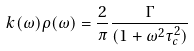Convert formula to latex. <formula><loc_0><loc_0><loc_500><loc_500>k ( \omega ) \rho ( \omega ) = \frac { 2 } { \pi } \frac { \Gamma } { ( 1 + \omega ^ { 2 } \tau _ { c } ^ { 2 } ) }</formula> 